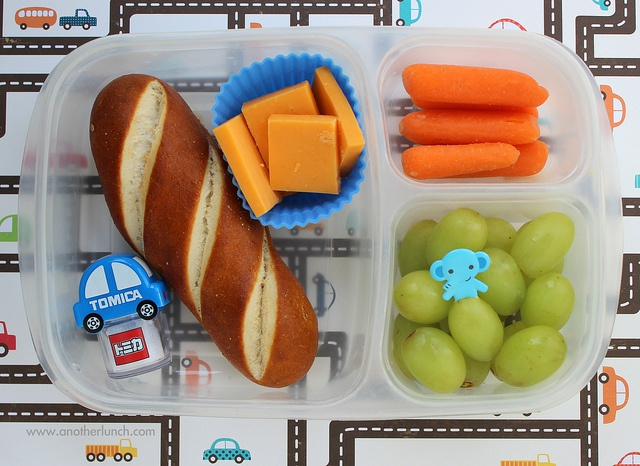Describe the objects in this image and their specific colors. I can see carrot in black, red, brown, and salmon tones, car in black, gray, lightblue, and blue tones, and hot dog in black, red, orange, and brown tones in this image. 